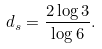<formula> <loc_0><loc_0><loc_500><loc_500>d _ { s } = \frac { 2 \log 3 } { \log 6 } .</formula> 